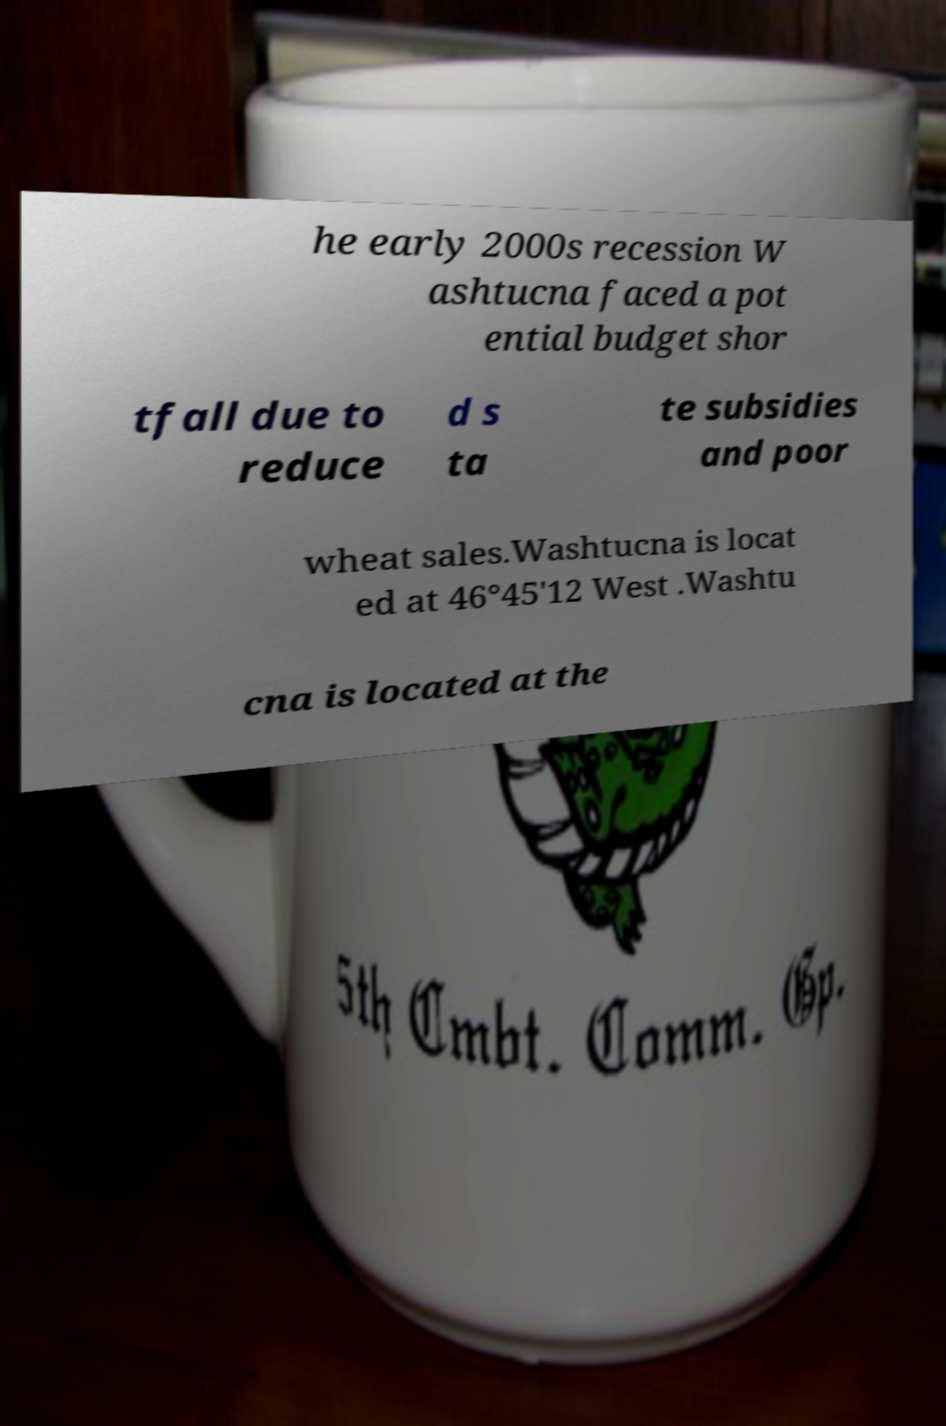Could you assist in decoding the text presented in this image and type it out clearly? he early 2000s recession W ashtucna faced a pot ential budget shor tfall due to reduce d s ta te subsidies and poor wheat sales.Washtucna is locat ed at 46°45'12 West .Washtu cna is located at the 